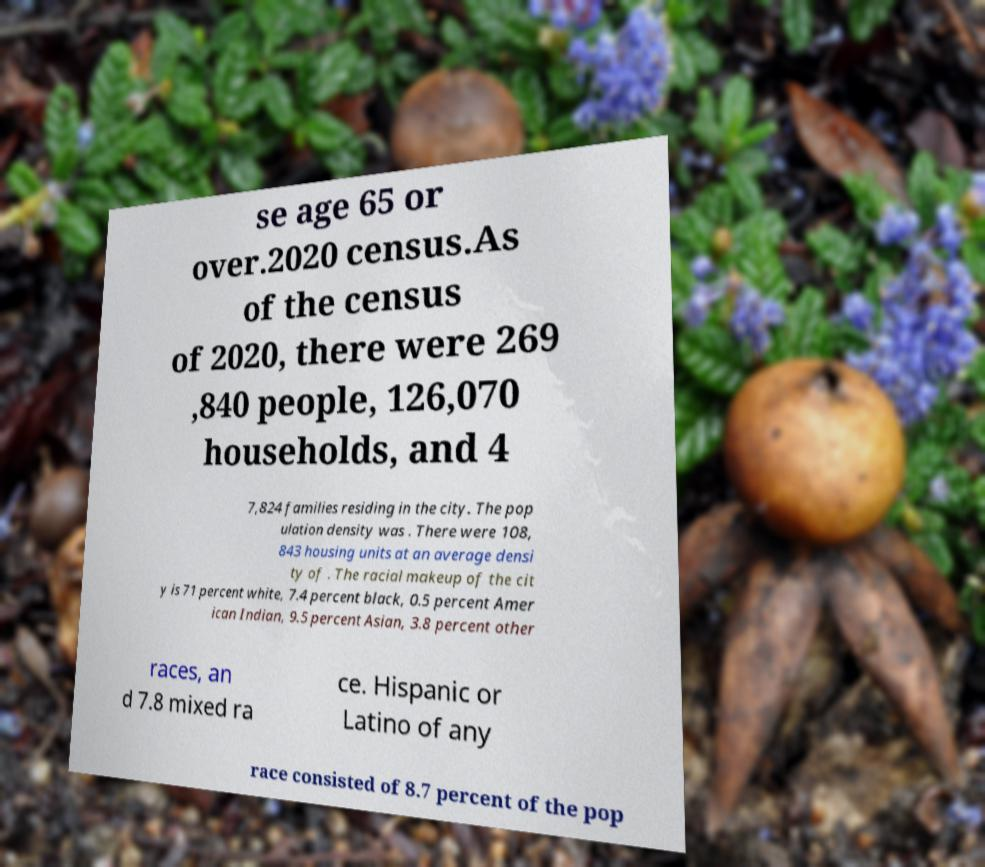For documentation purposes, I need the text within this image transcribed. Could you provide that? se age 65 or over.2020 census.As of the census of 2020, there were 269 ,840 people, 126,070 households, and 4 7,824 families residing in the city. The pop ulation density was . There were 108, 843 housing units at an average densi ty of . The racial makeup of the cit y is 71 percent white, 7.4 percent black, 0.5 percent Amer ican Indian, 9.5 percent Asian, 3.8 percent other races, an d 7.8 mixed ra ce. Hispanic or Latino of any race consisted of 8.7 percent of the pop 